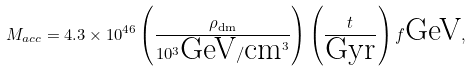<formula> <loc_0><loc_0><loc_500><loc_500>M _ { a c c } = 4 . 3 \times 1 0 ^ { 4 6 } \left ( \frac { \rho _ { \text {dm} } } { 1 0 ^ { 3 } \text {GeV} / \text {cm} ^ { 3 } } \right ) \left ( \frac { t } { \text {Gyr} } \right ) f \text {GeV} ,</formula> 